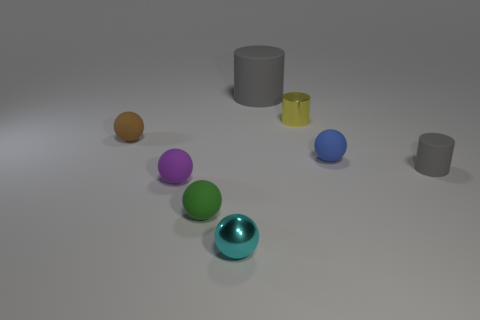Subtract 2 balls. How many balls are left? 3 Subtract all brown balls. How many balls are left? 4 Subtract all cyan balls. How many balls are left? 4 Subtract all red balls. Subtract all purple cylinders. How many balls are left? 5 Add 1 gray rubber objects. How many objects exist? 9 Subtract all spheres. How many objects are left? 3 Add 4 purple balls. How many purple balls are left? 5 Add 5 cyan objects. How many cyan objects exist? 6 Subtract 0 brown cubes. How many objects are left? 8 Subtract all small blue rubber spheres. Subtract all yellow things. How many objects are left? 6 